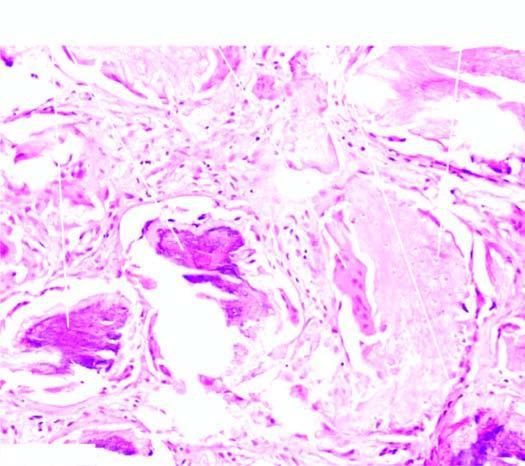re the air spaces also seen?
Answer the question using a single word or phrase. No 